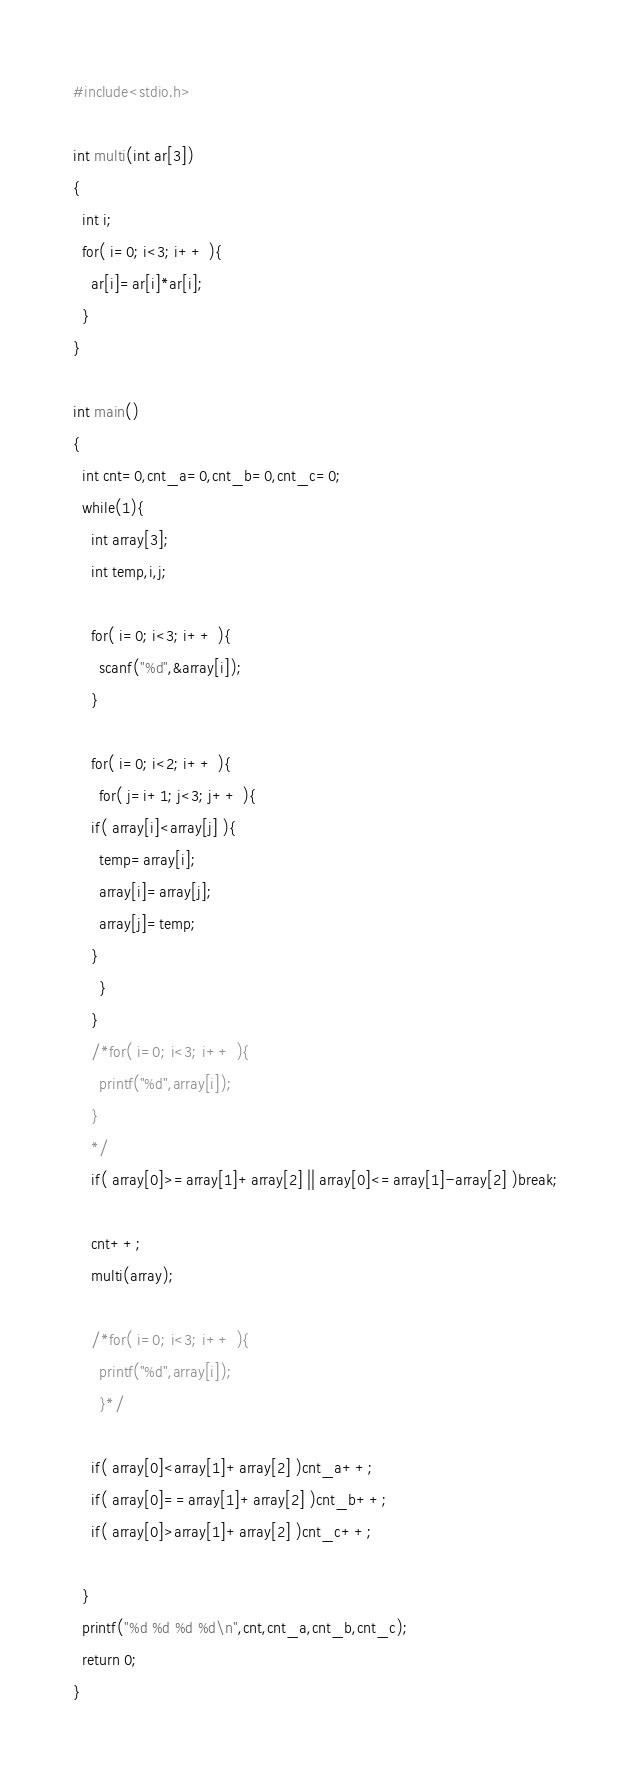Convert code to text. <code><loc_0><loc_0><loc_500><loc_500><_C_>#include<stdio.h>

int multi(int ar[3])
{
  int i;
  for( i=0; i<3; i++ ){
    ar[i]=ar[i]*ar[i];
  }
}

int main()
{
  int cnt=0,cnt_a=0,cnt_b=0,cnt_c=0; 
  while(1){
    int array[3];
    int temp,i,j;

    for( i=0; i<3; i++ ){
      scanf("%d",&array[i]);
    }

    for( i=0; i<2; i++ ){
      for( j=i+1; j<3; j++ ){
	if( array[i]<array[j] ){
	  temp=array[i];
	  array[i]=array[j];
	  array[j]=temp;
	}
      }
    }
    /*for( i=0; i<3; i++ ){
      printf("%d",array[i]);
    }
    */
    if( array[0]>=array[1]+array[2] || array[0]<=array[1]-array[2] )break;

    cnt++;
    multi(array);
   
    /*for( i=0; i<3; i++ ){
      printf("%d",array[i]);
      }*/

    if( array[0]<array[1]+array[2] )cnt_a++;
    if( array[0]==array[1]+array[2] )cnt_b++;
    if( array[0]>array[1]+array[2] )cnt_c++;
    
  }
  printf("%d %d %d %d\n",cnt,cnt_a,cnt_b,cnt_c);
  return 0;
}</code> 